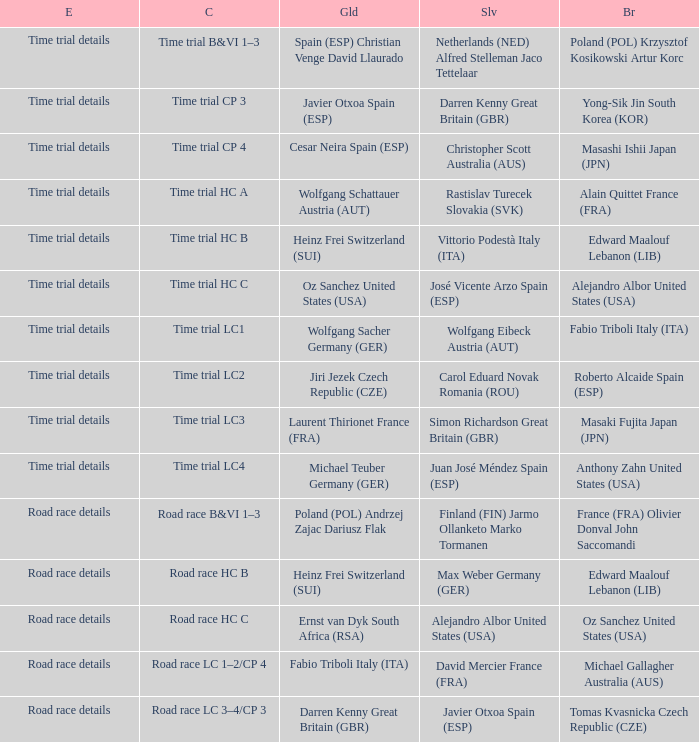Who received gold when the event is road race details and silver is max weber germany (ger)? Heinz Frei Switzerland (SUI). Can you give me this table as a dict? {'header': ['E', 'C', 'Gld', 'Slv', 'Br'], 'rows': [['Time trial details', 'Time trial B&VI 1–3', 'Spain (ESP) Christian Venge David Llaurado', 'Netherlands (NED) Alfred Stelleman Jaco Tettelaar', 'Poland (POL) Krzysztof Kosikowski Artur Korc'], ['Time trial details', 'Time trial CP 3', 'Javier Otxoa Spain (ESP)', 'Darren Kenny Great Britain (GBR)', 'Yong-Sik Jin South Korea (KOR)'], ['Time trial details', 'Time trial CP 4', 'Cesar Neira Spain (ESP)', 'Christopher Scott Australia (AUS)', 'Masashi Ishii Japan (JPN)'], ['Time trial details', 'Time trial HC A', 'Wolfgang Schattauer Austria (AUT)', 'Rastislav Turecek Slovakia (SVK)', 'Alain Quittet France (FRA)'], ['Time trial details', 'Time trial HC B', 'Heinz Frei Switzerland (SUI)', 'Vittorio Podestà Italy (ITA)', 'Edward Maalouf Lebanon (LIB)'], ['Time trial details', 'Time trial HC C', 'Oz Sanchez United States (USA)', 'José Vicente Arzo Spain (ESP)', 'Alejandro Albor United States (USA)'], ['Time trial details', 'Time trial LC1', 'Wolfgang Sacher Germany (GER)', 'Wolfgang Eibeck Austria (AUT)', 'Fabio Triboli Italy (ITA)'], ['Time trial details', 'Time trial LC2', 'Jiri Jezek Czech Republic (CZE)', 'Carol Eduard Novak Romania (ROU)', 'Roberto Alcaide Spain (ESP)'], ['Time trial details', 'Time trial LC3', 'Laurent Thirionet France (FRA)', 'Simon Richardson Great Britain (GBR)', 'Masaki Fujita Japan (JPN)'], ['Time trial details', 'Time trial LC4', 'Michael Teuber Germany (GER)', 'Juan José Méndez Spain (ESP)', 'Anthony Zahn United States (USA)'], ['Road race details', 'Road race B&VI 1–3', 'Poland (POL) Andrzej Zajac Dariusz Flak', 'Finland (FIN) Jarmo Ollanketo Marko Tormanen', 'France (FRA) Olivier Donval John Saccomandi'], ['Road race details', 'Road race HC B', 'Heinz Frei Switzerland (SUI)', 'Max Weber Germany (GER)', 'Edward Maalouf Lebanon (LIB)'], ['Road race details', 'Road race HC C', 'Ernst van Dyk South Africa (RSA)', 'Alejandro Albor United States (USA)', 'Oz Sanchez United States (USA)'], ['Road race details', 'Road race LC 1–2/CP 4', 'Fabio Triboli Italy (ITA)', 'David Mercier France (FRA)', 'Michael Gallagher Australia (AUS)'], ['Road race details', 'Road race LC 3–4/CP 3', 'Darren Kenny Great Britain (GBR)', 'Javier Otxoa Spain (ESP)', 'Tomas Kvasnicka Czech Republic (CZE)']]} 